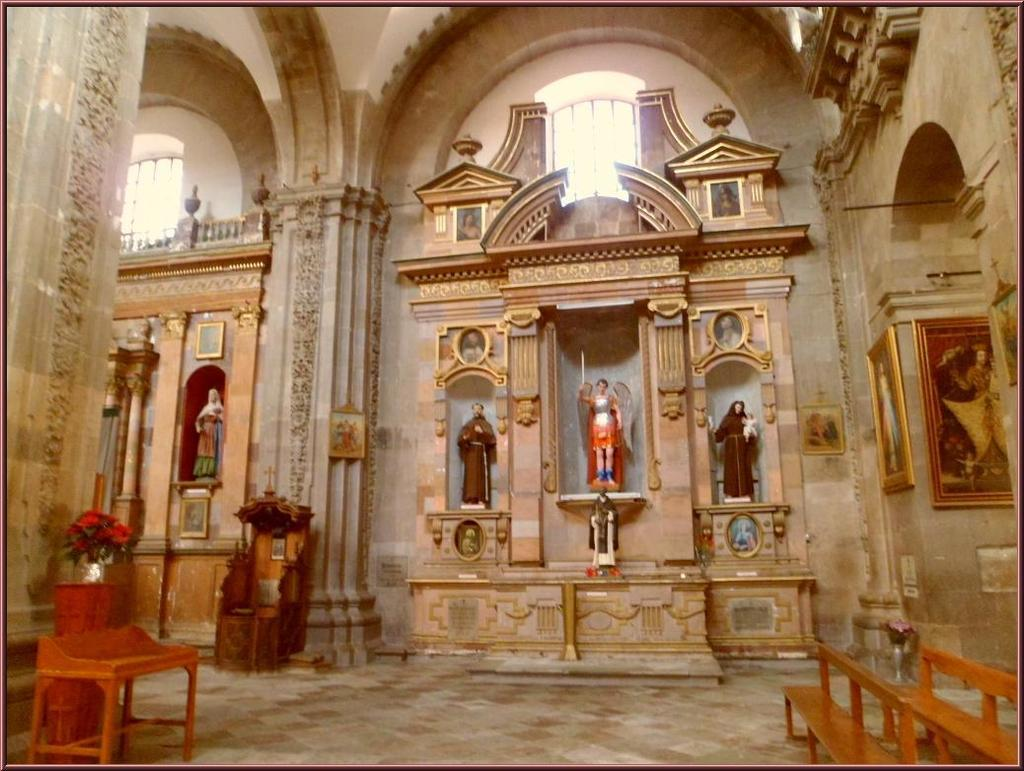What type of location is depicted in the image? The image is an inside view of a building. What decorative elements can be seen in the image? There are statues, frames on the wall, stands, benches, and flower vases in the image. What part of the building is visible in the image? There is a floor visible in the image. What type of mine is visible in the image? There is no mine present in the image; it is an inside view of a building with various decorative elements. Can you see a rifle in the image? There is no rifle present in the image. 